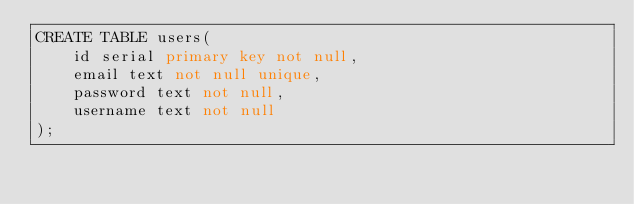<code> <loc_0><loc_0><loc_500><loc_500><_SQL_>CREATE TABLE users(
    id serial primary key not null,
    email text not null unique,
    password text not null,
    username text not null
);</code> 